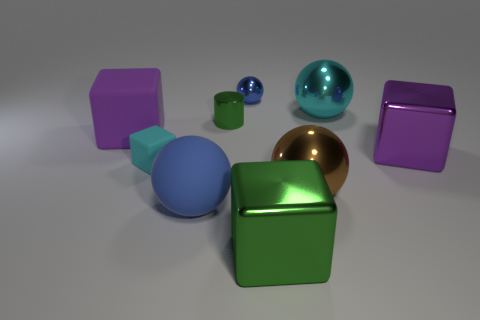Subtract all brown shiny spheres. How many spheres are left? 3 Add 1 tiny matte objects. How many objects exist? 10 Subtract all spheres. How many objects are left? 5 Subtract 1 cylinders. How many cylinders are left? 0 Subtract all yellow cylinders. How many cyan cubes are left? 1 Subtract all tiny blue metal things. Subtract all tiny balls. How many objects are left? 7 Add 7 cyan things. How many cyan things are left? 9 Add 2 brown rubber blocks. How many brown rubber blocks exist? 2 Subtract all cyan blocks. How many blocks are left? 3 Subtract 0 red balls. How many objects are left? 9 